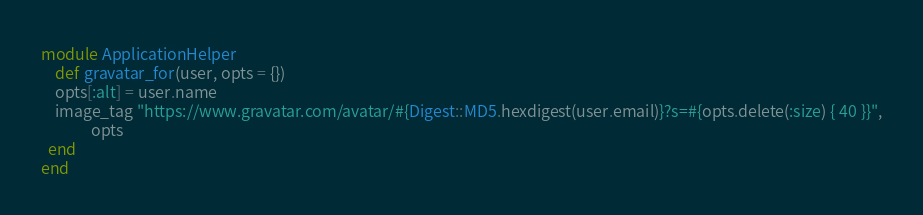<code> <loc_0><loc_0><loc_500><loc_500><_Ruby_>module ApplicationHelper
	def gravatar_for(user, opts = {})
    opts[:alt] = user.name
    image_tag "https://www.gravatar.com/avatar/#{Digest::MD5.hexdigest(user.email)}?s=#{opts.delete(:size) { 40 }}",
              opts
  end
end
</code> 